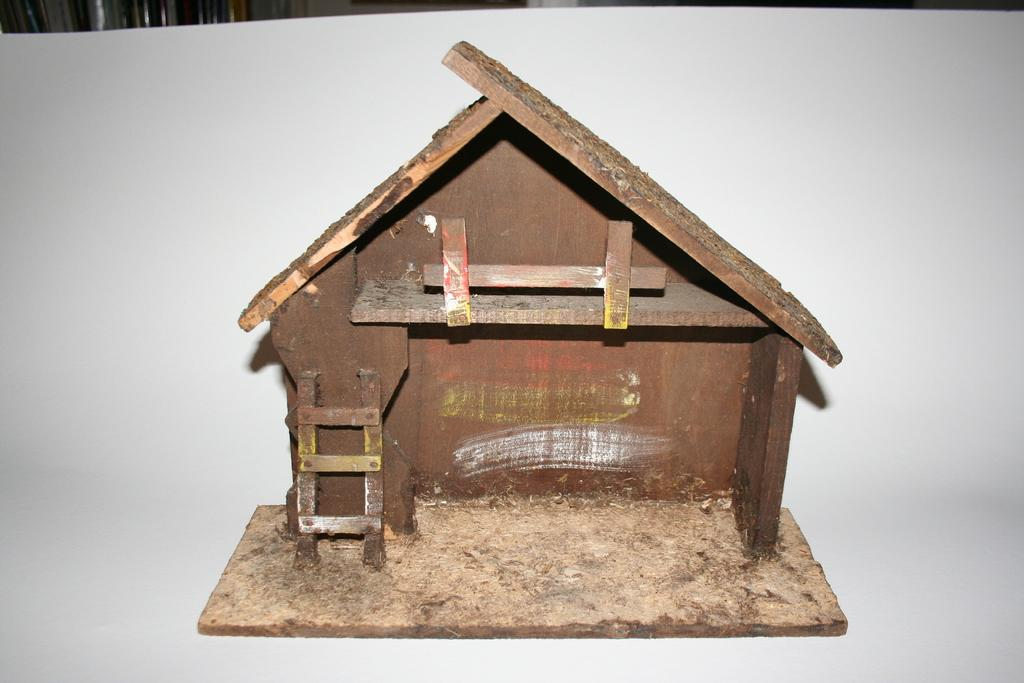What is the main subject of the image? There is a brown-colored miniature shack in the image. What color is the miniature shack? The miniature shack is brown. What color is the background of the image? The background of the image is white. How many potatoes are visible in the image? There are no potatoes present in the image. What type of account is being discussed in the image? There is no account being discussed in the image. 